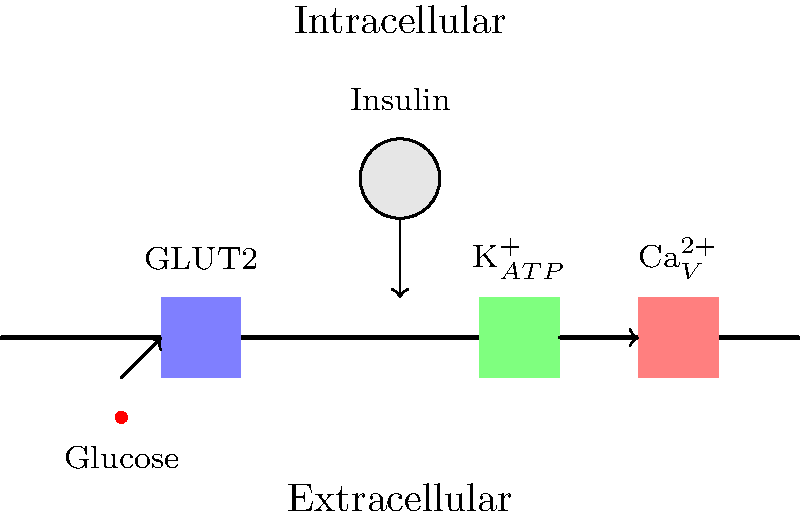In the process of glucose-stimulated insulin secretion from pancreatic beta cells, which ion channel closure is crucial for initiating membrane depolarization, and how does this lead to insulin release? The process of glucose-stimulated insulin secretion involves several steps:

1. Glucose enters the beta cell through GLUT2 transporters.

2. Glucose is metabolized, increasing the ATP/ADP ratio.

3. The increased ATP/ADP ratio causes closure of ATP-sensitive K+ (K$_{ATP}$) channels.

4. K$_{ATP}$ channel closure leads to membrane depolarization because K+ ions can no longer efflux from the cell.

5. Membrane depolarization activates voltage-gated Ca2+ channels.

6. Ca2+ influx through these channels increases intracellular Ca2+ concentration.

7. The rise in intracellular Ca2+ triggers the exocytosis of insulin-containing granules.

The closure of K$_{ATP}$ channels is crucial because it initiates the depolarization cascade. Without this step, the subsequent events leading to insulin release would not occur.
Answer: K$_{ATP}$ channel closure 